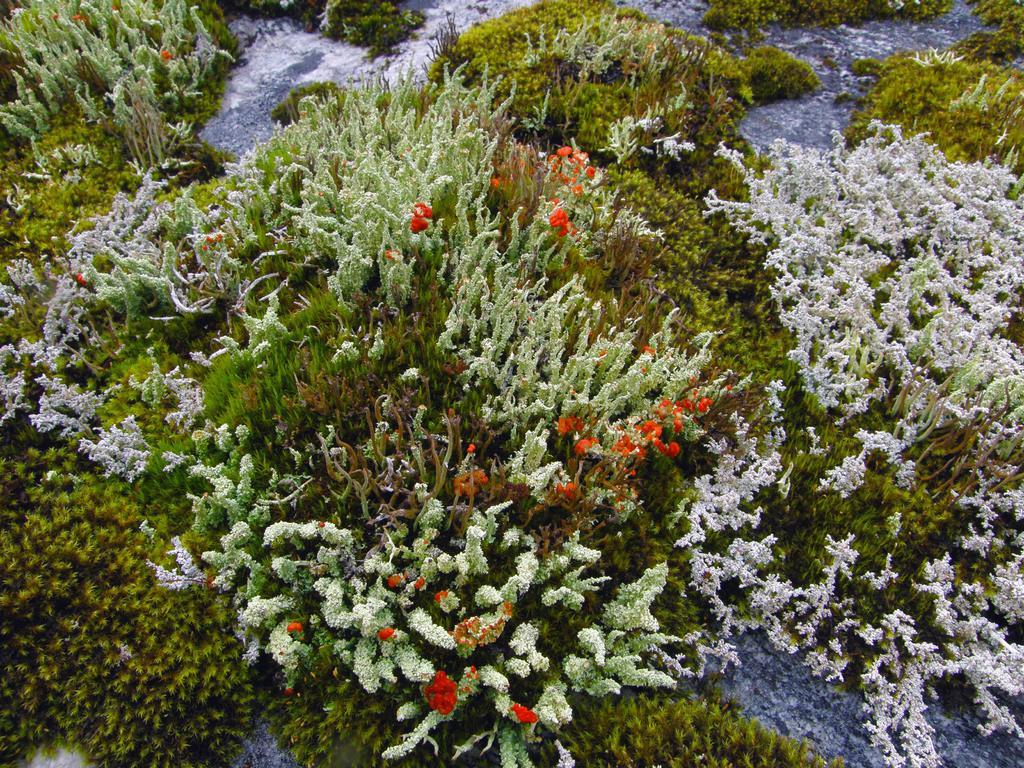Could you give a brief overview of what you see in this image? There are few plants which are in different colors. 